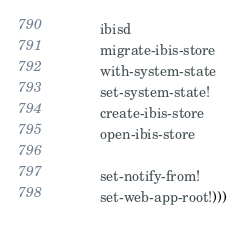Convert code to text. <code><loc_0><loc_0><loc_500><loc_500><_Scheme_>           ibisd
           migrate-ibis-store
           with-system-state
           set-system-state!
           create-ibis-store
           open-ibis-store
           
           set-notify-from!
           set-web-app-root!)))
</code> 